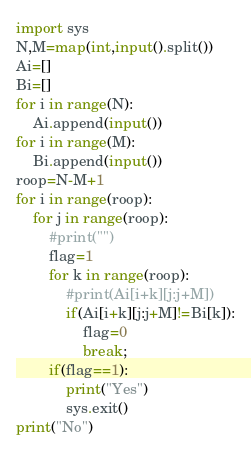<code> <loc_0><loc_0><loc_500><loc_500><_Python_>import sys
N,M=map(int,input().split())
Ai=[]
Bi=[]
for i in range(N):
    Ai.append(input())
for i in range(M):
    Bi.append(input())
roop=N-M+1
for i in range(roop):
    for j in range(roop):
        #print("")
        flag=1
        for k in range(roop):
            #print(Ai[i+k][j:j+M])
            if(Ai[i+k][j:j+M]!=Bi[k]):
                flag=0
                break;
        if(flag==1):
            print("Yes")
            sys.exit()
print("No")
</code> 